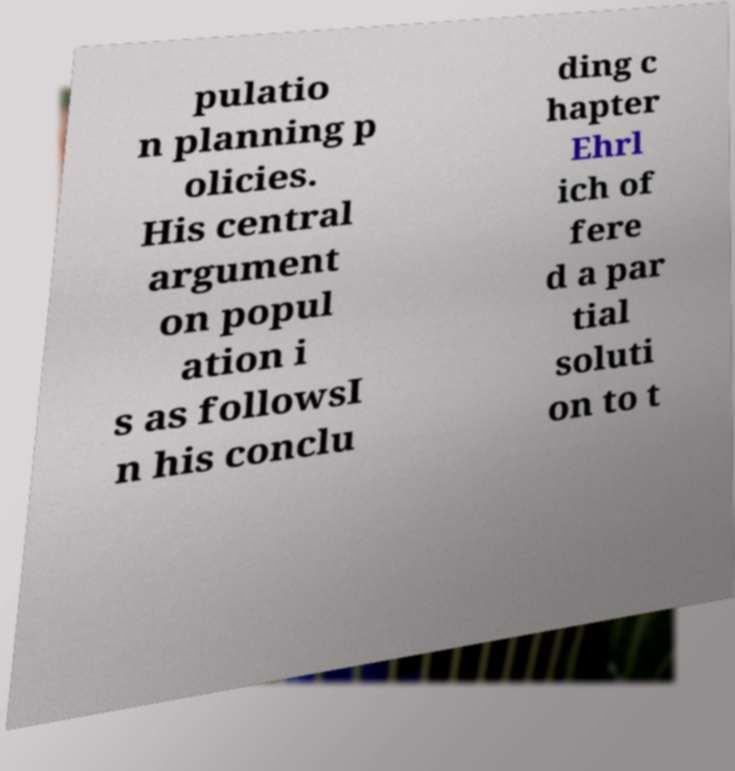Can you read and provide the text displayed in the image?This photo seems to have some interesting text. Can you extract and type it out for me? pulatio n planning p olicies. His central argument on popul ation i s as followsI n his conclu ding c hapter Ehrl ich of fere d a par tial soluti on to t 